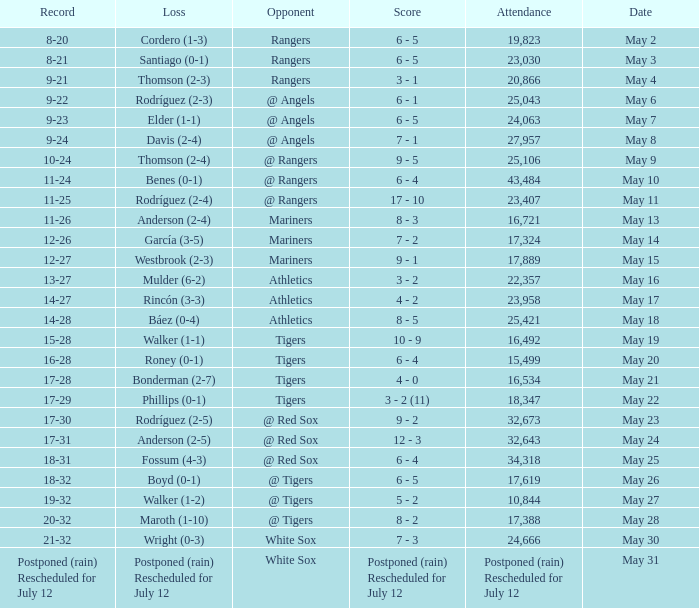What date did the Indians have a record of 14-28? May 18. 